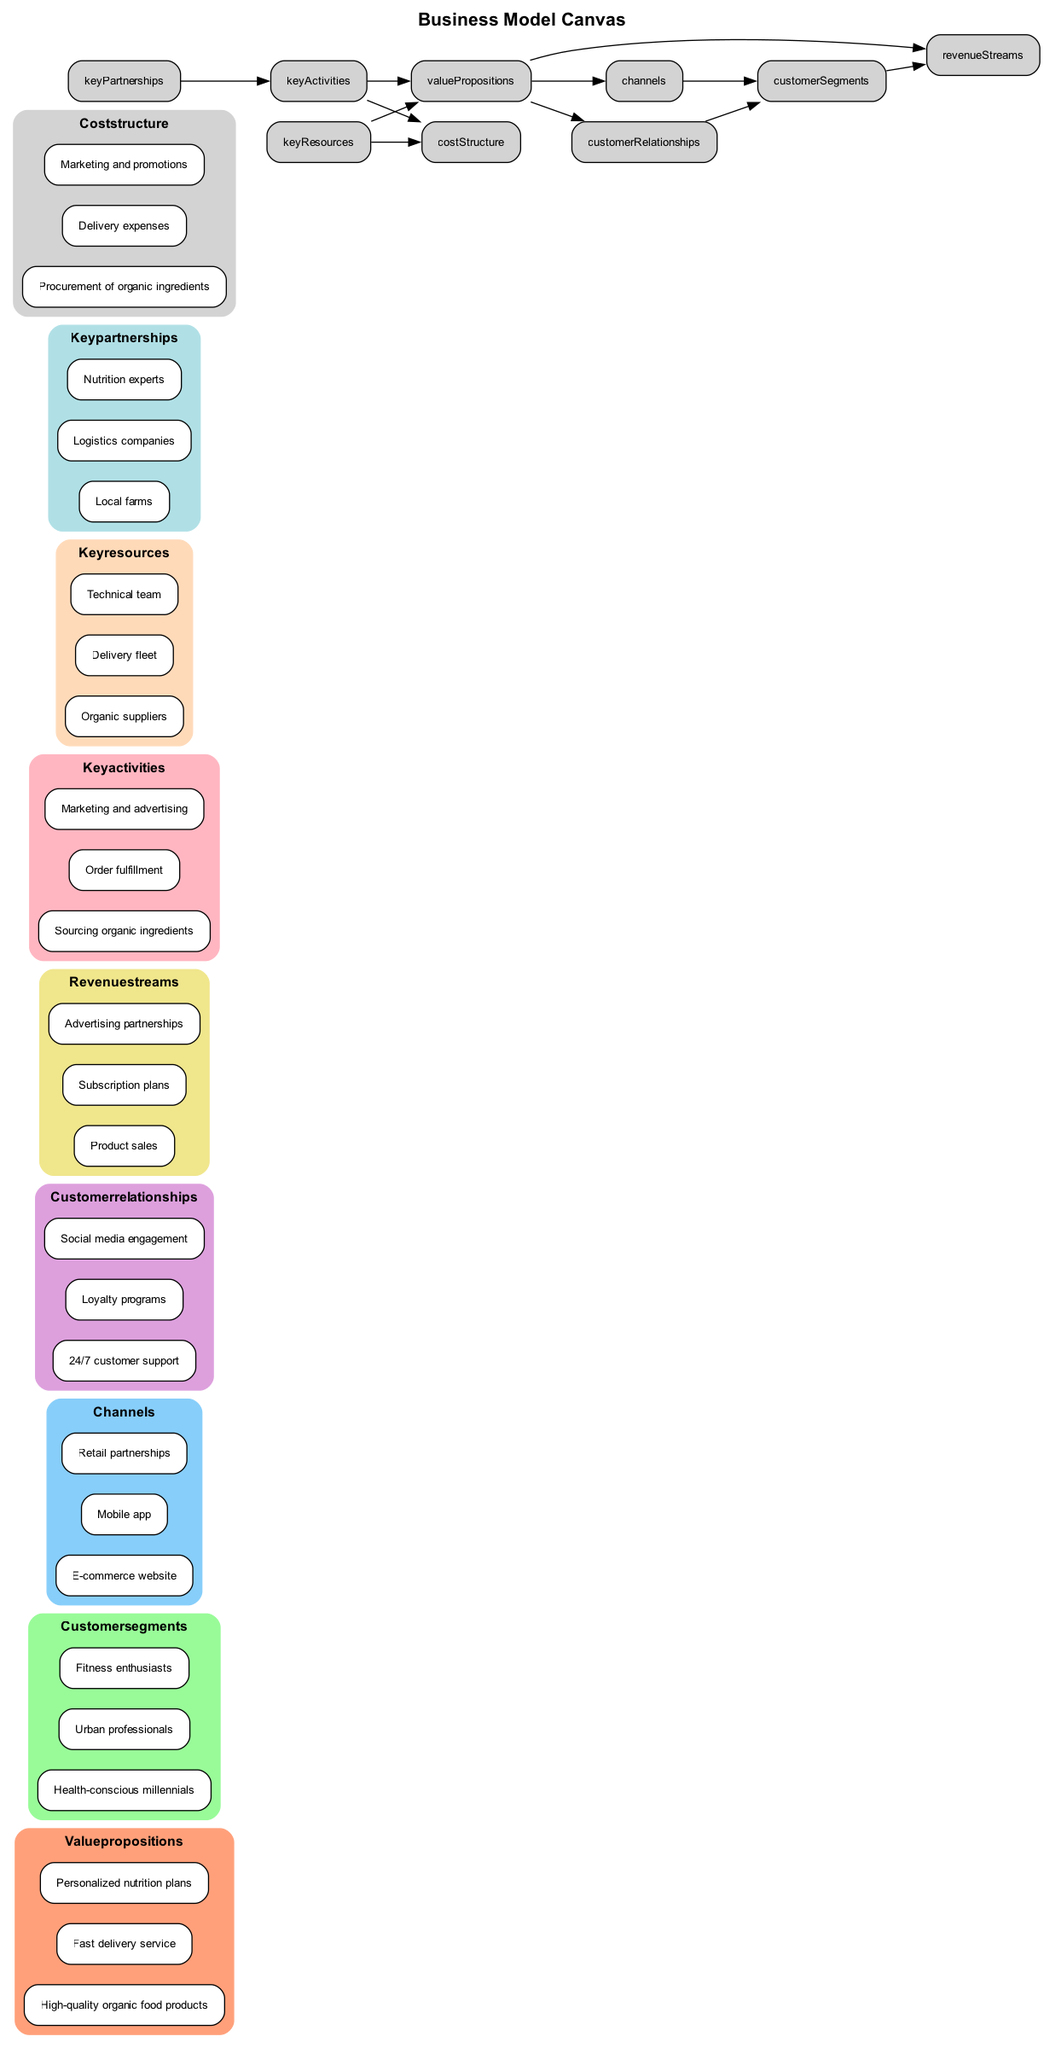What are the three value propositions listed? The value propositions section contains three items: "High-quality organic food products," "Fast delivery service," and "Personalized nutrition plans."
Answer: High-quality organic food products, Fast delivery service, Personalized nutrition plans How many customer segments are identified? The customer segments section lists three groups: "Health-conscious millennials," "Urban professionals," and "Fitness enthusiasts." Hence, there are three segments.
Answer: 3 Which section is connected to both revenue streams and value propositions? The revenue streams section has a direct connection with the value propositions section as indicated by the edges drawn between them. The value propositions serve as the origin for these streams.
Answer: Value propositions What are the key activities associated with partnerships? The key activities section identifies activities such as "Sourcing organic ingredients," "Order fulfillment," and "Marketing and advertising." These all link back to the partnerships through value propositions, indicating that they are interconnected.
Answer: Sourcing organic ingredients, Order fulfillment, Marketing and advertising Which customer segment is linked to channels? The channels section connects to "customer segments" through the edge that emerges from it, indicating that the flow of services and products goes from channels to respective customer segments, leading to the listed segments, which include "Health-conscious millennials," "Urban professionals," and "Fitness enthusiasts."
Answer: Health-conscious millennials, Urban professionals, Fitness enthusiasts Which element in the diagram has the most edges connecting to it? Upon reviewing the diagram, the value propositions section connects to five other sections: customer relationships, channels, revenue streams, key activities, and key resources. Therefore, it possesses the most interconnections.
Answer: Value propositions What is the first node connected to revenue streams? The edge leading to revenue streams is directly preceded by the value propositions, which clearly establishes it as the originating node for this connection.
Answer: Value propositions What represents the cost incurred for procurement? The cost structure provides a detailed overview of expenses, including the particular cost for procurement of organic ingredients. This specific cost is directly listed within the cost structure section.
Answer: Procurement of organic ingredients 